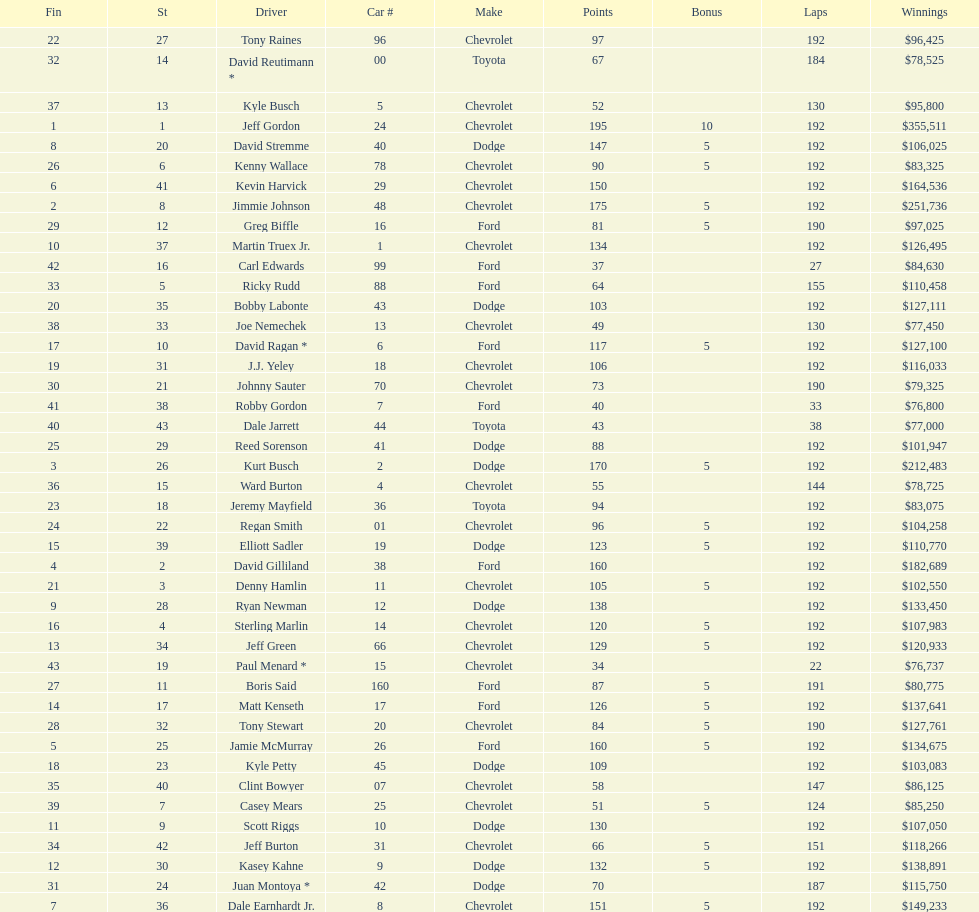How many drivers placed below tony stewart? 15. 